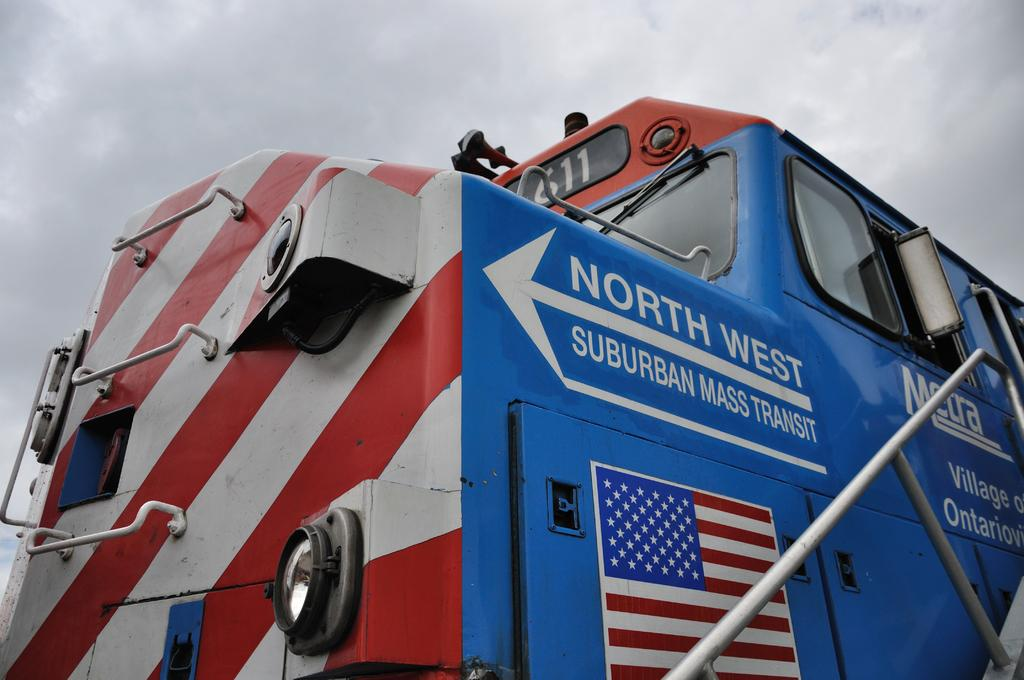What is the main subject of the image? There is a train in the center of the image. Can you describe the train in the image? The train is the main subject, and it is located in the center of the image. What might be the purpose of the train in the image? The purpose of the train in the image is not explicitly stated, but it could be for transportation or display. How many brothers are sitting on the tray in the image? There is no tray or brothers present in the image; it features a train in the center. 